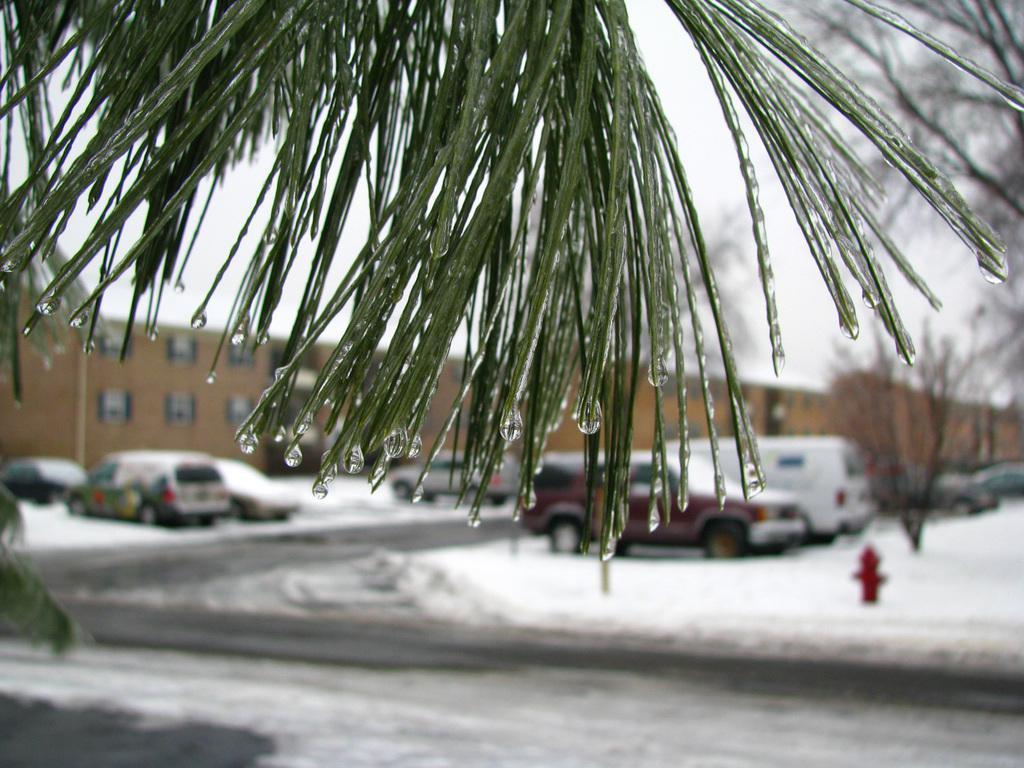How would you summarize this image in a sentence or two? In this image I can see a tree which is in green color, at the back I can see a pole in red color, few vehicles, snow in white color, a building in brown color. At the top sky is in white color. 